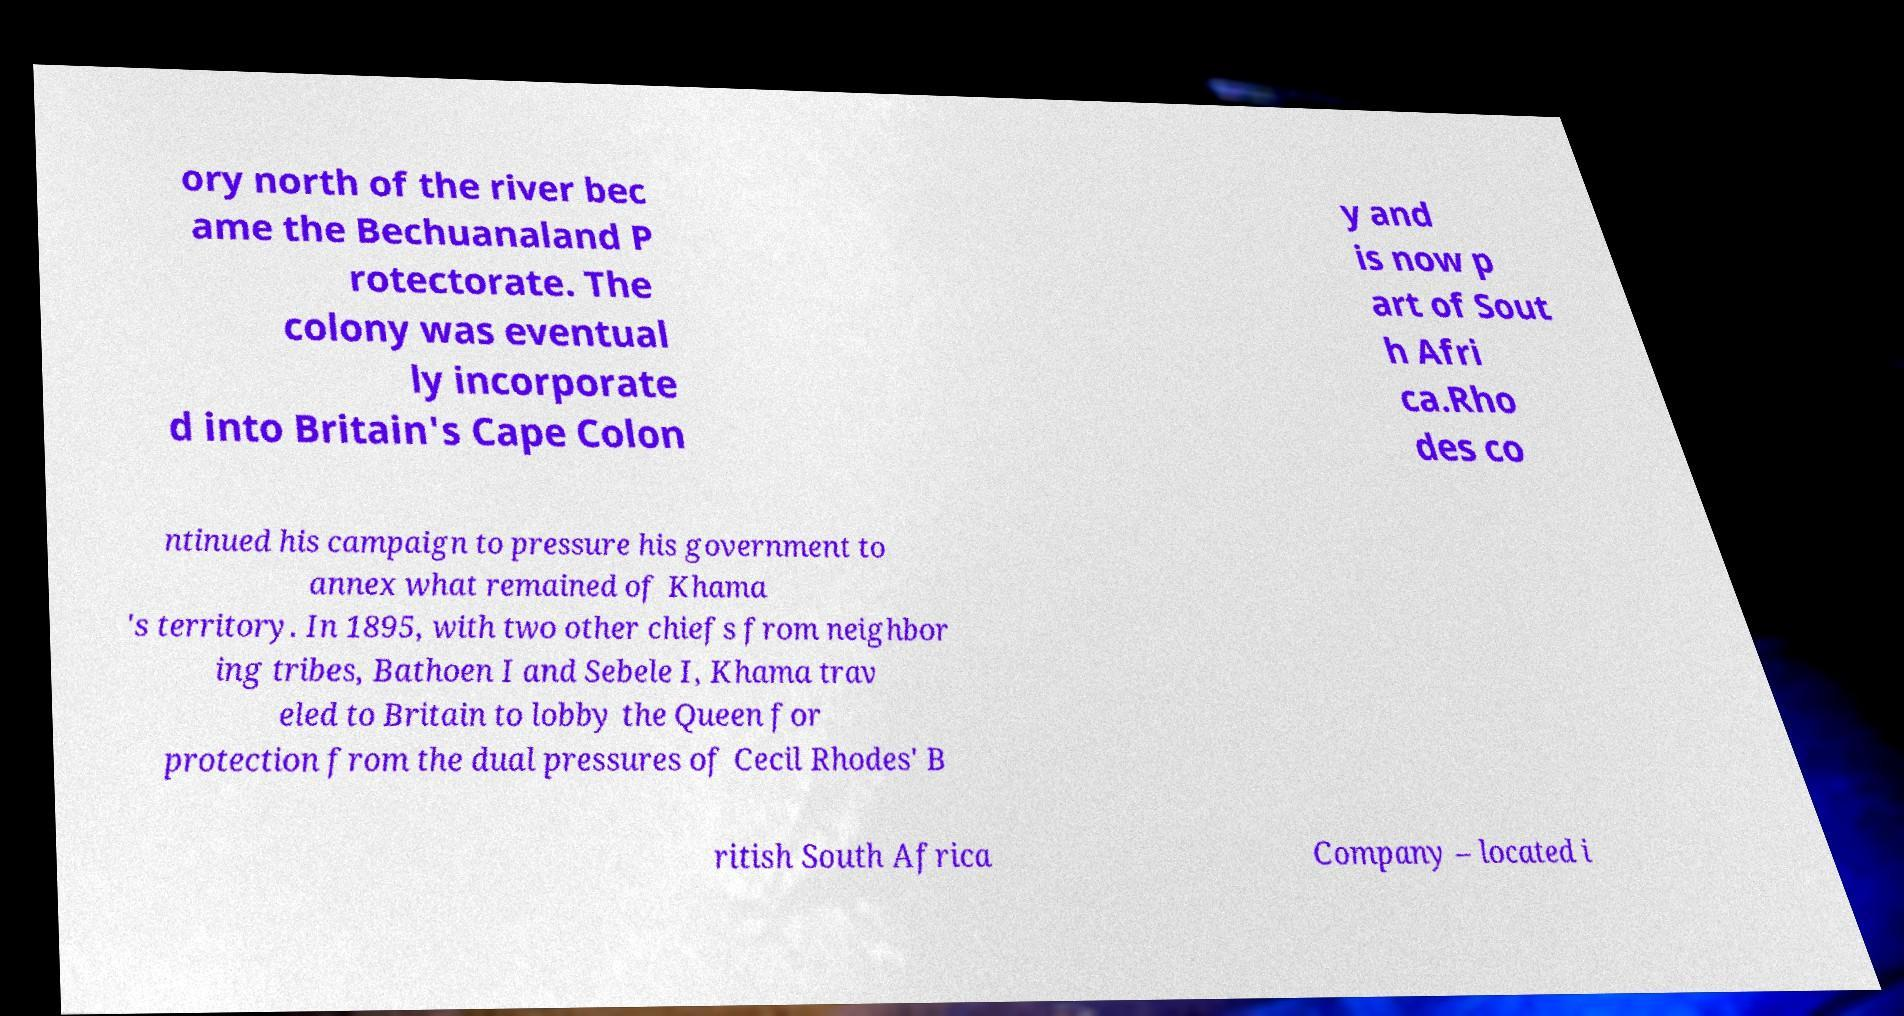I need the written content from this picture converted into text. Can you do that? ory north of the river bec ame the Bechuanaland P rotectorate. The colony was eventual ly incorporate d into Britain's Cape Colon y and is now p art of Sout h Afri ca.Rho des co ntinued his campaign to pressure his government to annex what remained of Khama 's territory. In 1895, with two other chiefs from neighbor ing tribes, Bathoen I and Sebele I, Khama trav eled to Britain to lobby the Queen for protection from the dual pressures of Cecil Rhodes' B ritish South Africa Company – located i 